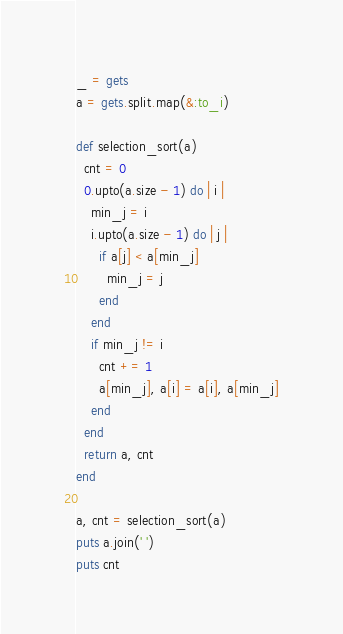<code> <loc_0><loc_0><loc_500><loc_500><_Ruby_>_ = gets
a = gets.split.map(&:to_i)

def selection_sort(a)
  cnt = 0
  0.upto(a.size - 1) do | i |
    min_j = i
    i.upto(a.size - 1) do | j |
      if a[j] < a[min_j]
        min_j = j
      end
    end
    if min_j != i
      cnt += 1
      a[min_j], a[i] = a[i], a[min_j]
    end
  end
  return a, cnt
end

a, cnt = selection_sort(a)
puts a.join(' ')
puts cnt

</code> 